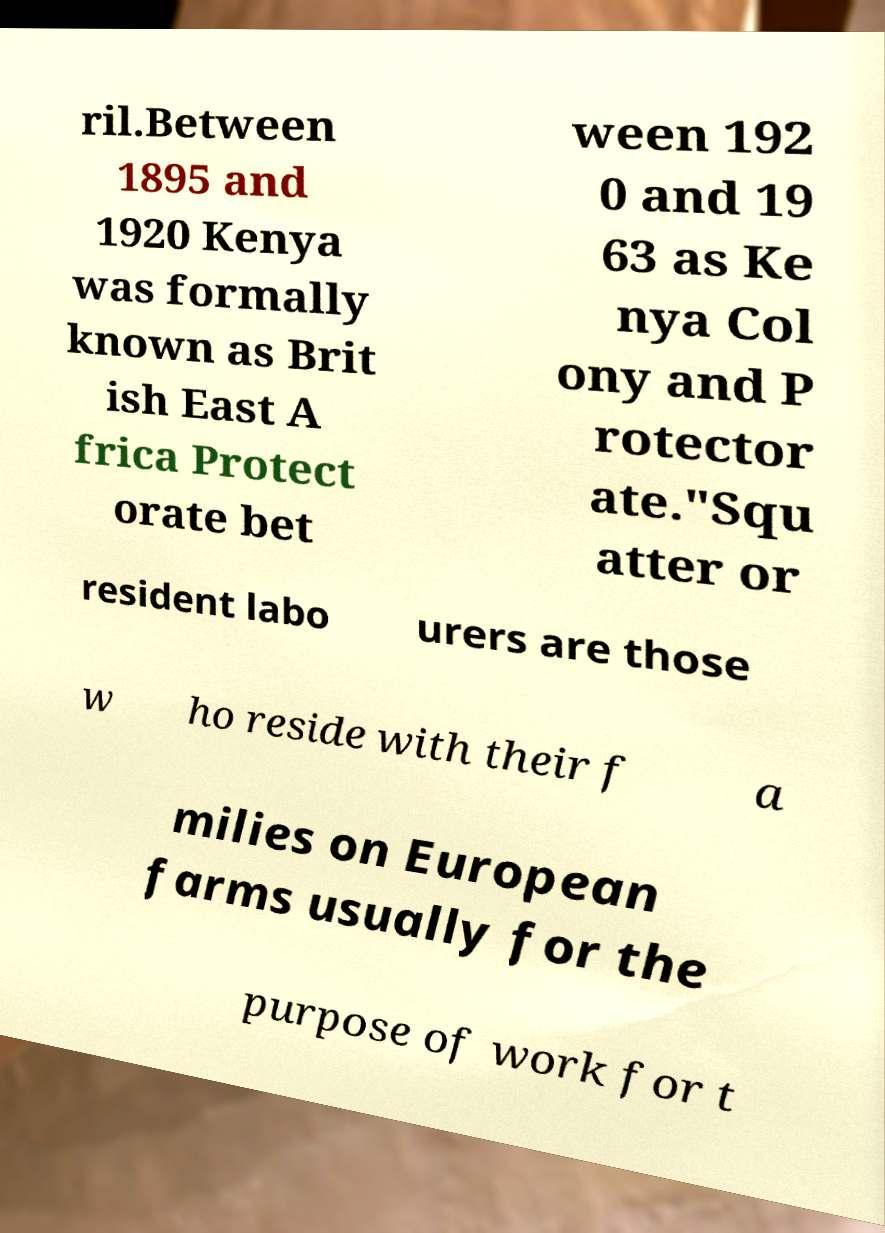There's text embedded in this image that I need extracted. Can you transcribe it verbatim? ril.Between 1895 and 1920 Kenya was formally known as Brit ish East A frica Protect orate bet ween 192 0 and 19 63 as Ke nya Col ony and P rotector ate."Squ atter or resident labo urers are those w ho reside with their f a milies on European farms usually for the purpose of work for t 